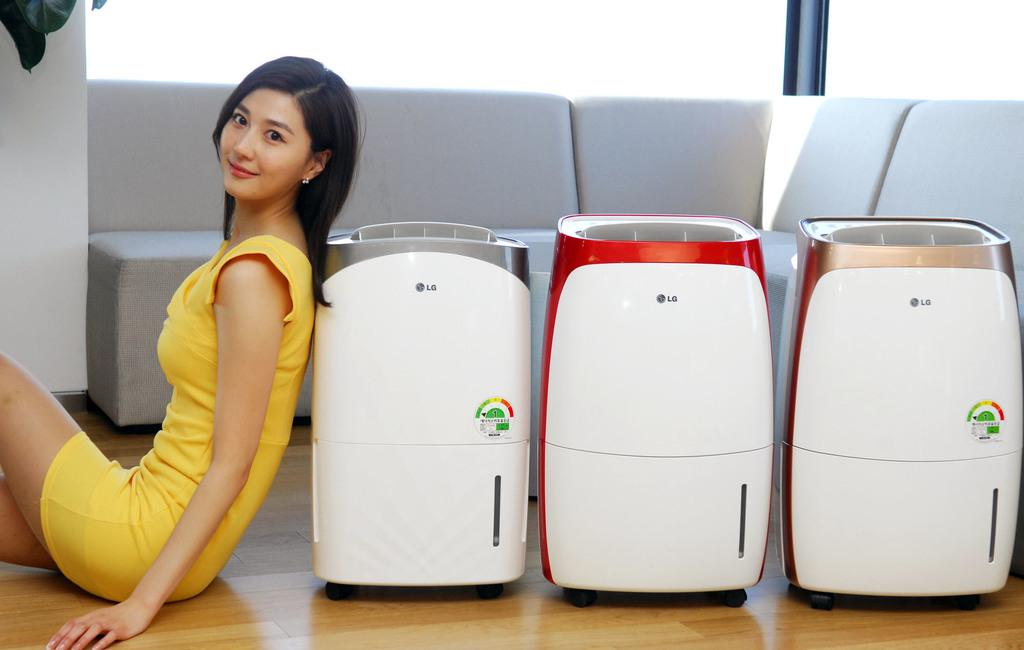What is the woman in the image doing? The woman is sitting on the floor in the image. What is the woman's facial expression in the image? The woman is smiling in the image. How many electrical devices can be seen in the image? There are three electrical devices in the image. What can be seen in the background of the image? There are chairs and a wall in the background of the image. What type of bean is being served at the feast in the image? There is no feast or bean present in the image. What type of juice is being consumed by the woman in the image? There is no juice present in the image; the woman is not consuming anything. 